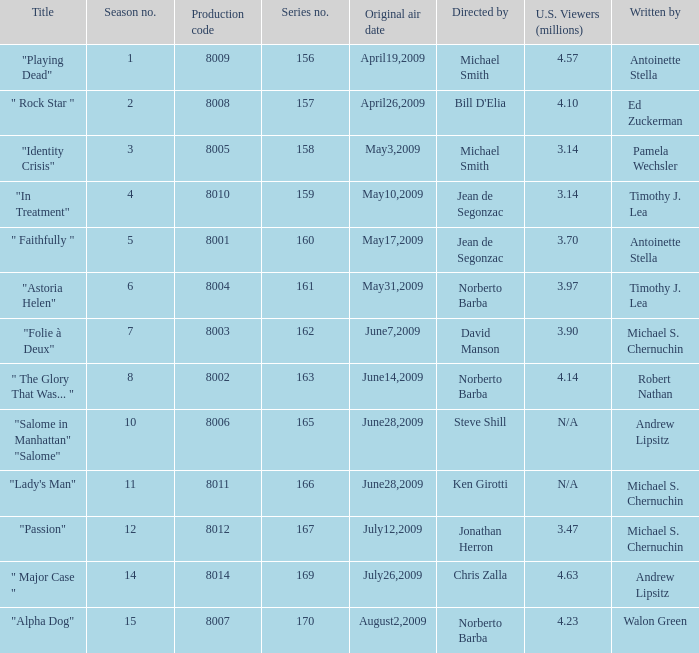Who are the writer of the series episode number 170? Walon Green. 